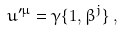Convert formula to latex. <formula><loc_0><loc_0><loc_500><loc_500>u ^ { \prime \mu } = \gamma \{ 1 , \beta ^ { j } \} \, ,</formula> 